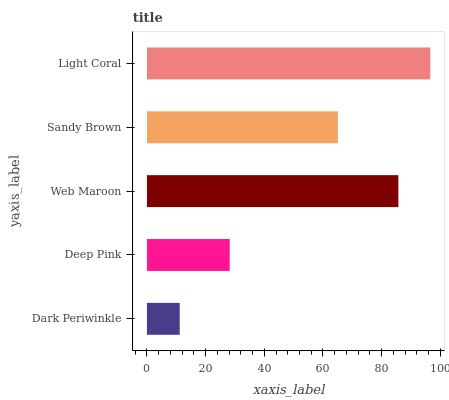Is Dark Periwinkle the minimum?
Answer yes or no. Yes. Is Light Coral the maximum?
Answer yes or no. Yes. Is Deep Pink the minimum?
Answer yes or no. No. Is Deep Pink the maximum?
Answer yes or no. No. Is Deep Pink greater than Dark Periwinkle?
Answer yes or no. Yes. Is Dark Periwinkle less than Deep Pink?
Answer yes or no. Yes. Is Dark Periwinkle greater than Deep Pink?
Answer yes or no. No. Is Deep Pink less than Dark Periwinkle?
Answer yes or no. No. Is Sandy Brown the high median?
Answer yes or no. Yes. Is Sandy Brown the low median?
Answer yes or no. Yes. Is Deep Pink the high median?
Answer yes or no. No. Is Light Coral the low median?
Answer yes or no. No. 